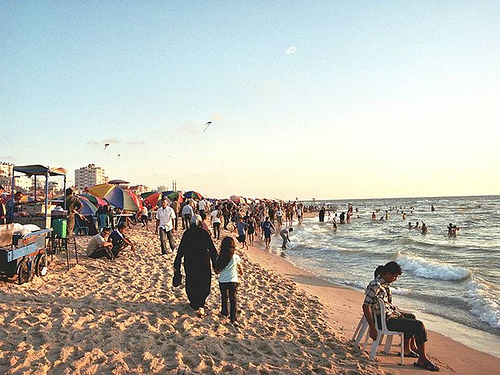Does the cart have red color? The cart does not feature any red color; it is primarily blue with some items loaded on it. 